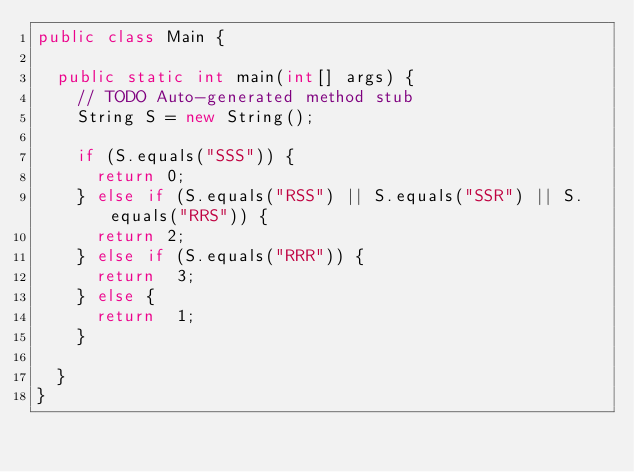<code> <loc_0><loc_0><loc_500><loc_500><_Java_>public class Main {

	public static int main(int[] args) {
		// TODO Auto-generated method stub
		String S = new String();
		
		if (S.equals("SSS")) {
			return 0;
		} else if (S.equals("RSS") || S.equals("SSR") || S.equals("RRS")) {
			return 2;
		} else if (S.equals("RRR")) {
			return  3;
		} else {
			return  1;
		}
		
	}
}</code> 